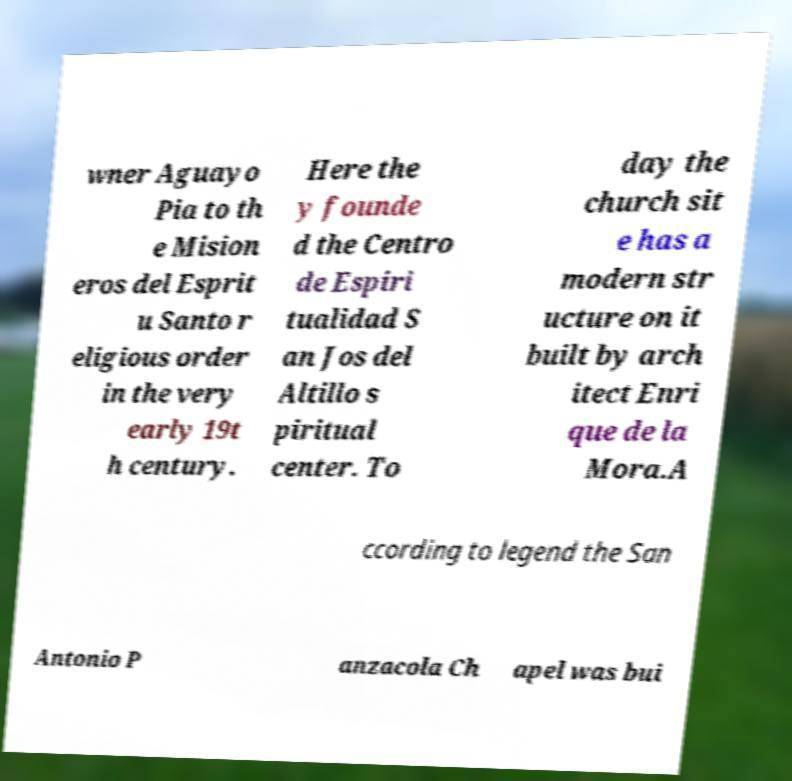Can you read and provide the text displayed in the image?This photo seems to have some interesting text. Can you extract and type it out for me? wner Aguayo Pia to th e Mision eros del Esprit u Santo r eligious order in the very early 19t h century. Here the y founde d the Centro de Espiri tualidad S an Jos del Altillo s piritual center. To day the church sit e has a modern str ucture on it built by arch itect Enri que de la Mora.A ccording to legend the San Antonio P anzacola Ch apel was bui 